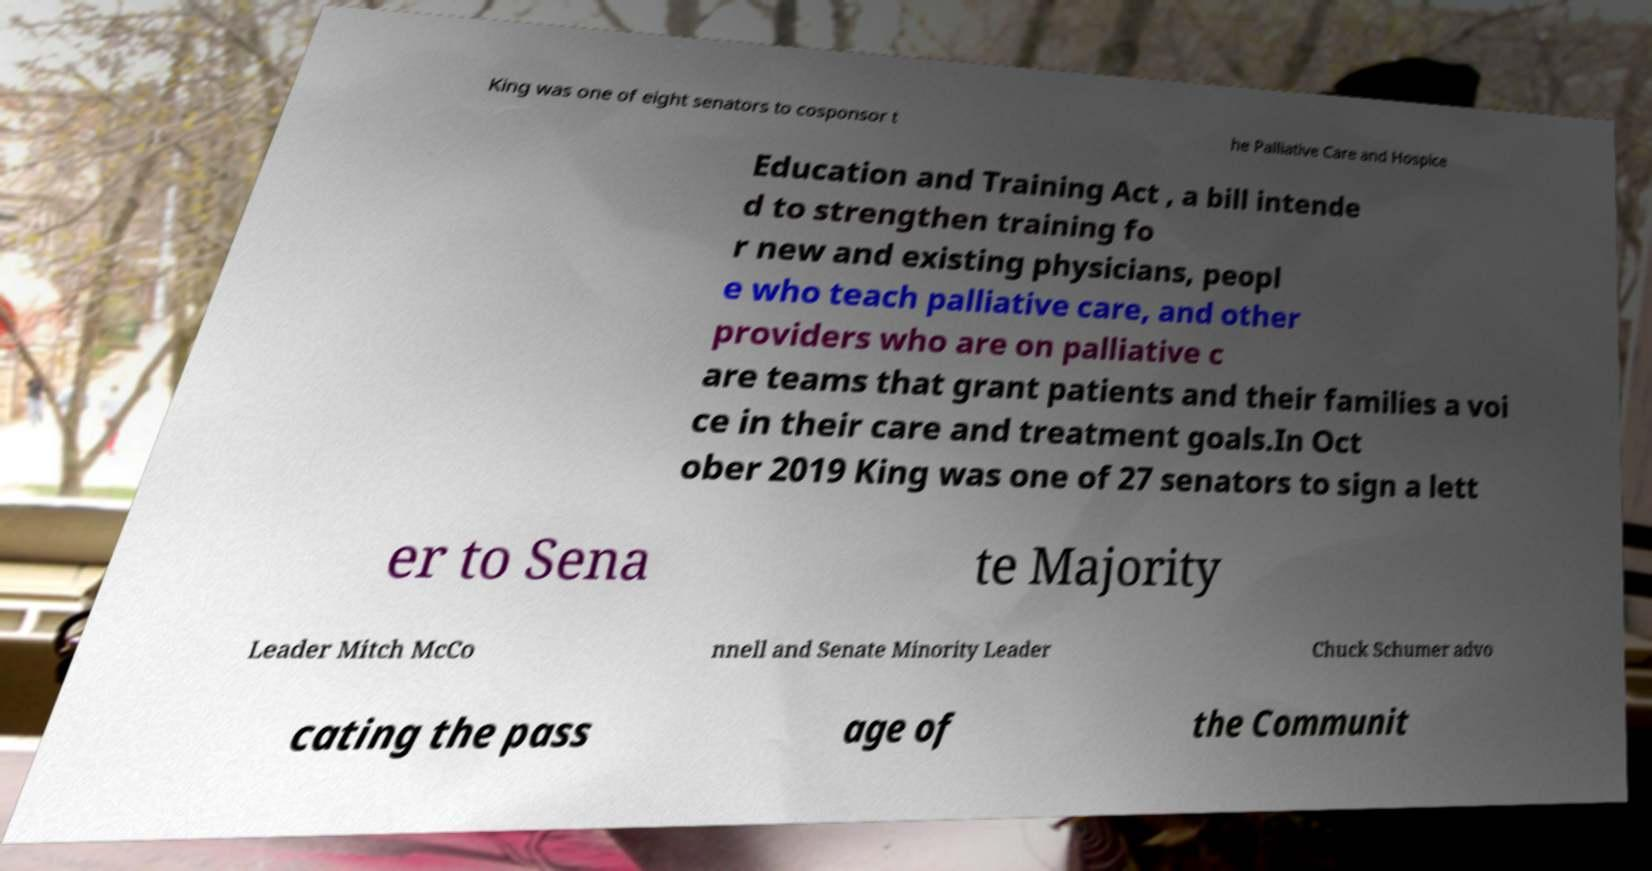For documentation purposes, I need the text within this image transcribed. Could you provide that? King was one of eight senators to cosponsor t he Palliative Care and Hospice Education and Training Act , a bill intende d to strengthen training fo r new and existing physicians, peopl e who teach palliative care, and other providers who are on palliative c are teams that grant patients and their families a voi ce in their care and treatment goals.In Oct ober 2019 King was one of 27 senators to sign a lett er to Sena te Majority Leader Mitch McCo nnell and Senate Minority Leader Chuck Schumer advo cating the pass age of the Communit 